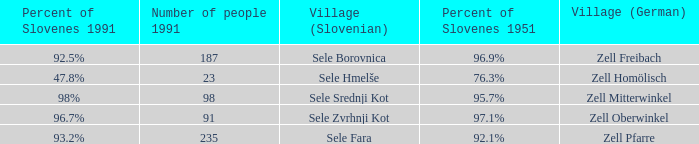Provide me with the name of all the village (German) that are part of the village (Slovenian) with sele borovnica. Zell Freibach. 